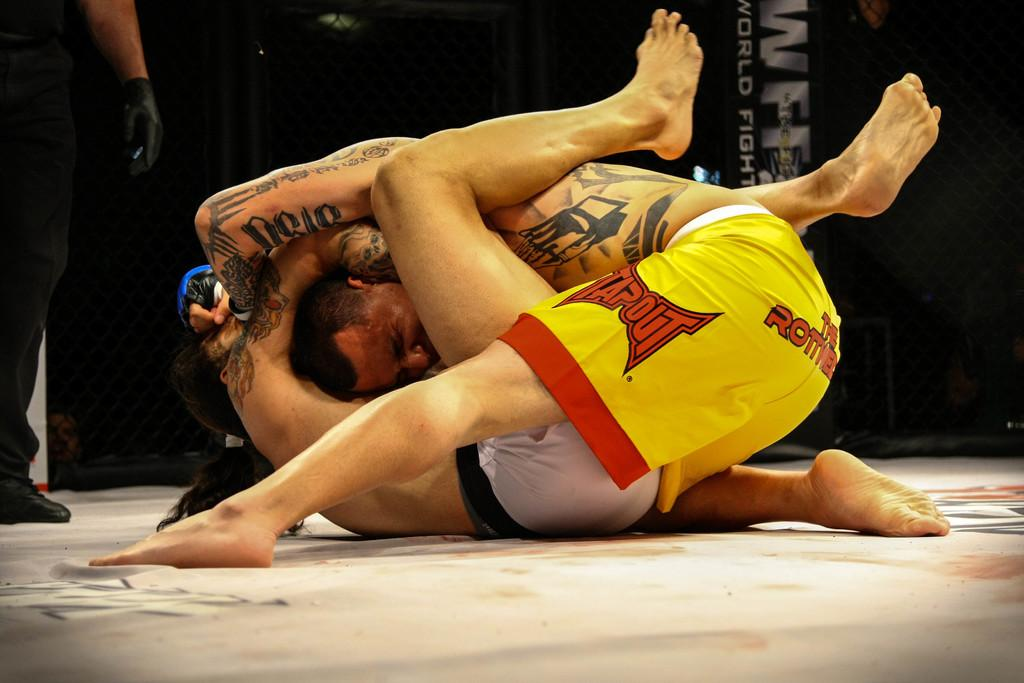<image>
Offer a succinct explanation of the picture presented. a person with yellow shorts that says Tapout on it 